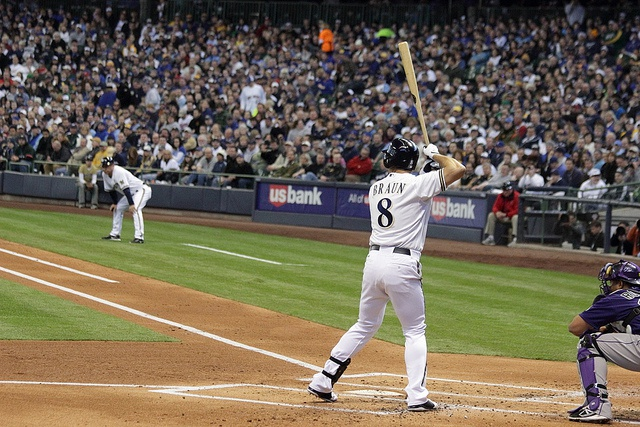Describe the objects in this image and their specific colors. I can see people in black, gray, and darkgray tones, people in black, lightgray, darkgray, and gray tones, people in black, darkgray, gray, and navy tones, people in black, lavender, darkgray, and gray tones, and people in black, maroon, and gray tones in this image. 